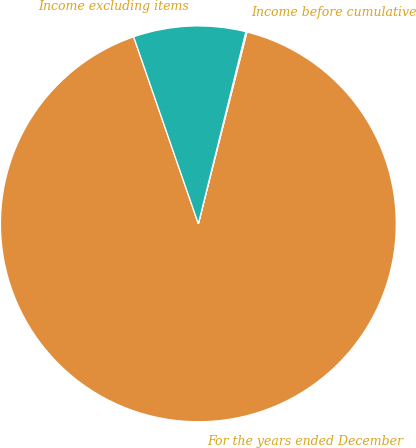Convert chart. <chart><loc_0><loc_0><loc_500><loc_500><pie_chart><fcel>For the years ended December<fcel>Income before cumulative<fcel>Income excluding items<nl><fcel>90.75%<fcel>0.09%<fcel>9.16%<nl></chart> 